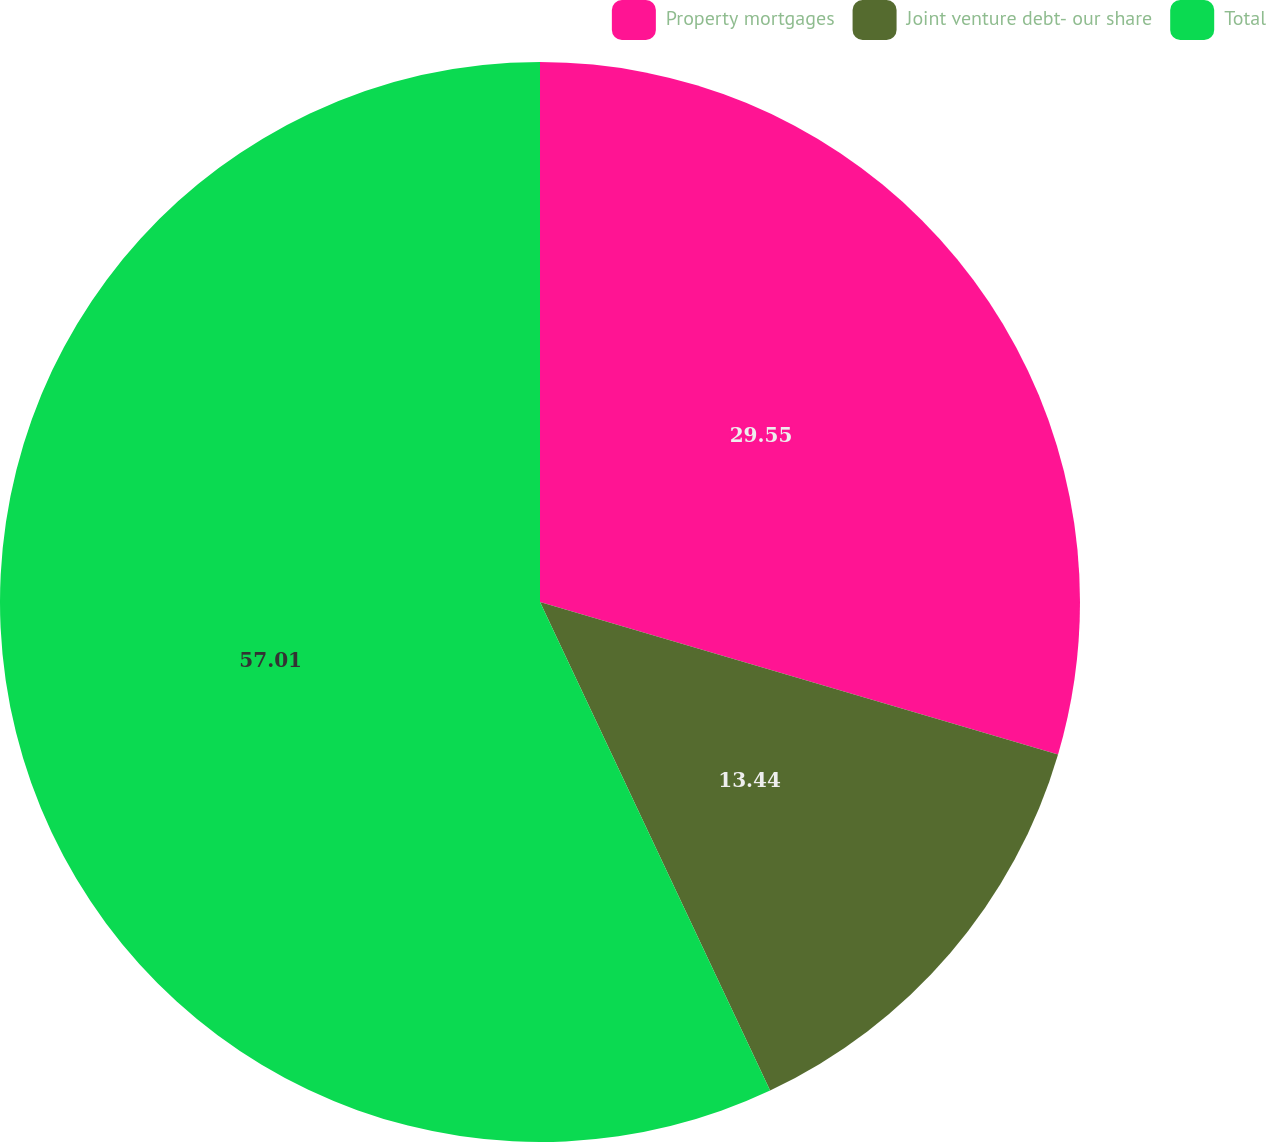<chart> <loc_0><loc_0><loc_500><loc_500><pie_chart><fcel>Property mortgages<fcel>Joint venture debt- our share<fcel>Total<nl><fcel>29.55%<fcel>13.44%<fcel>57.0%<nl></chart> 